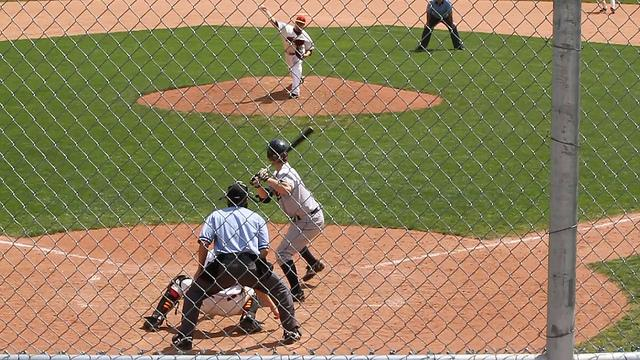The fence is placed in front of what part of the stadium to stop the pitchers fastball from hitting it? Please explain your reasoning. all correct. The ball could hurt people and damage things if it flew out of the field. 